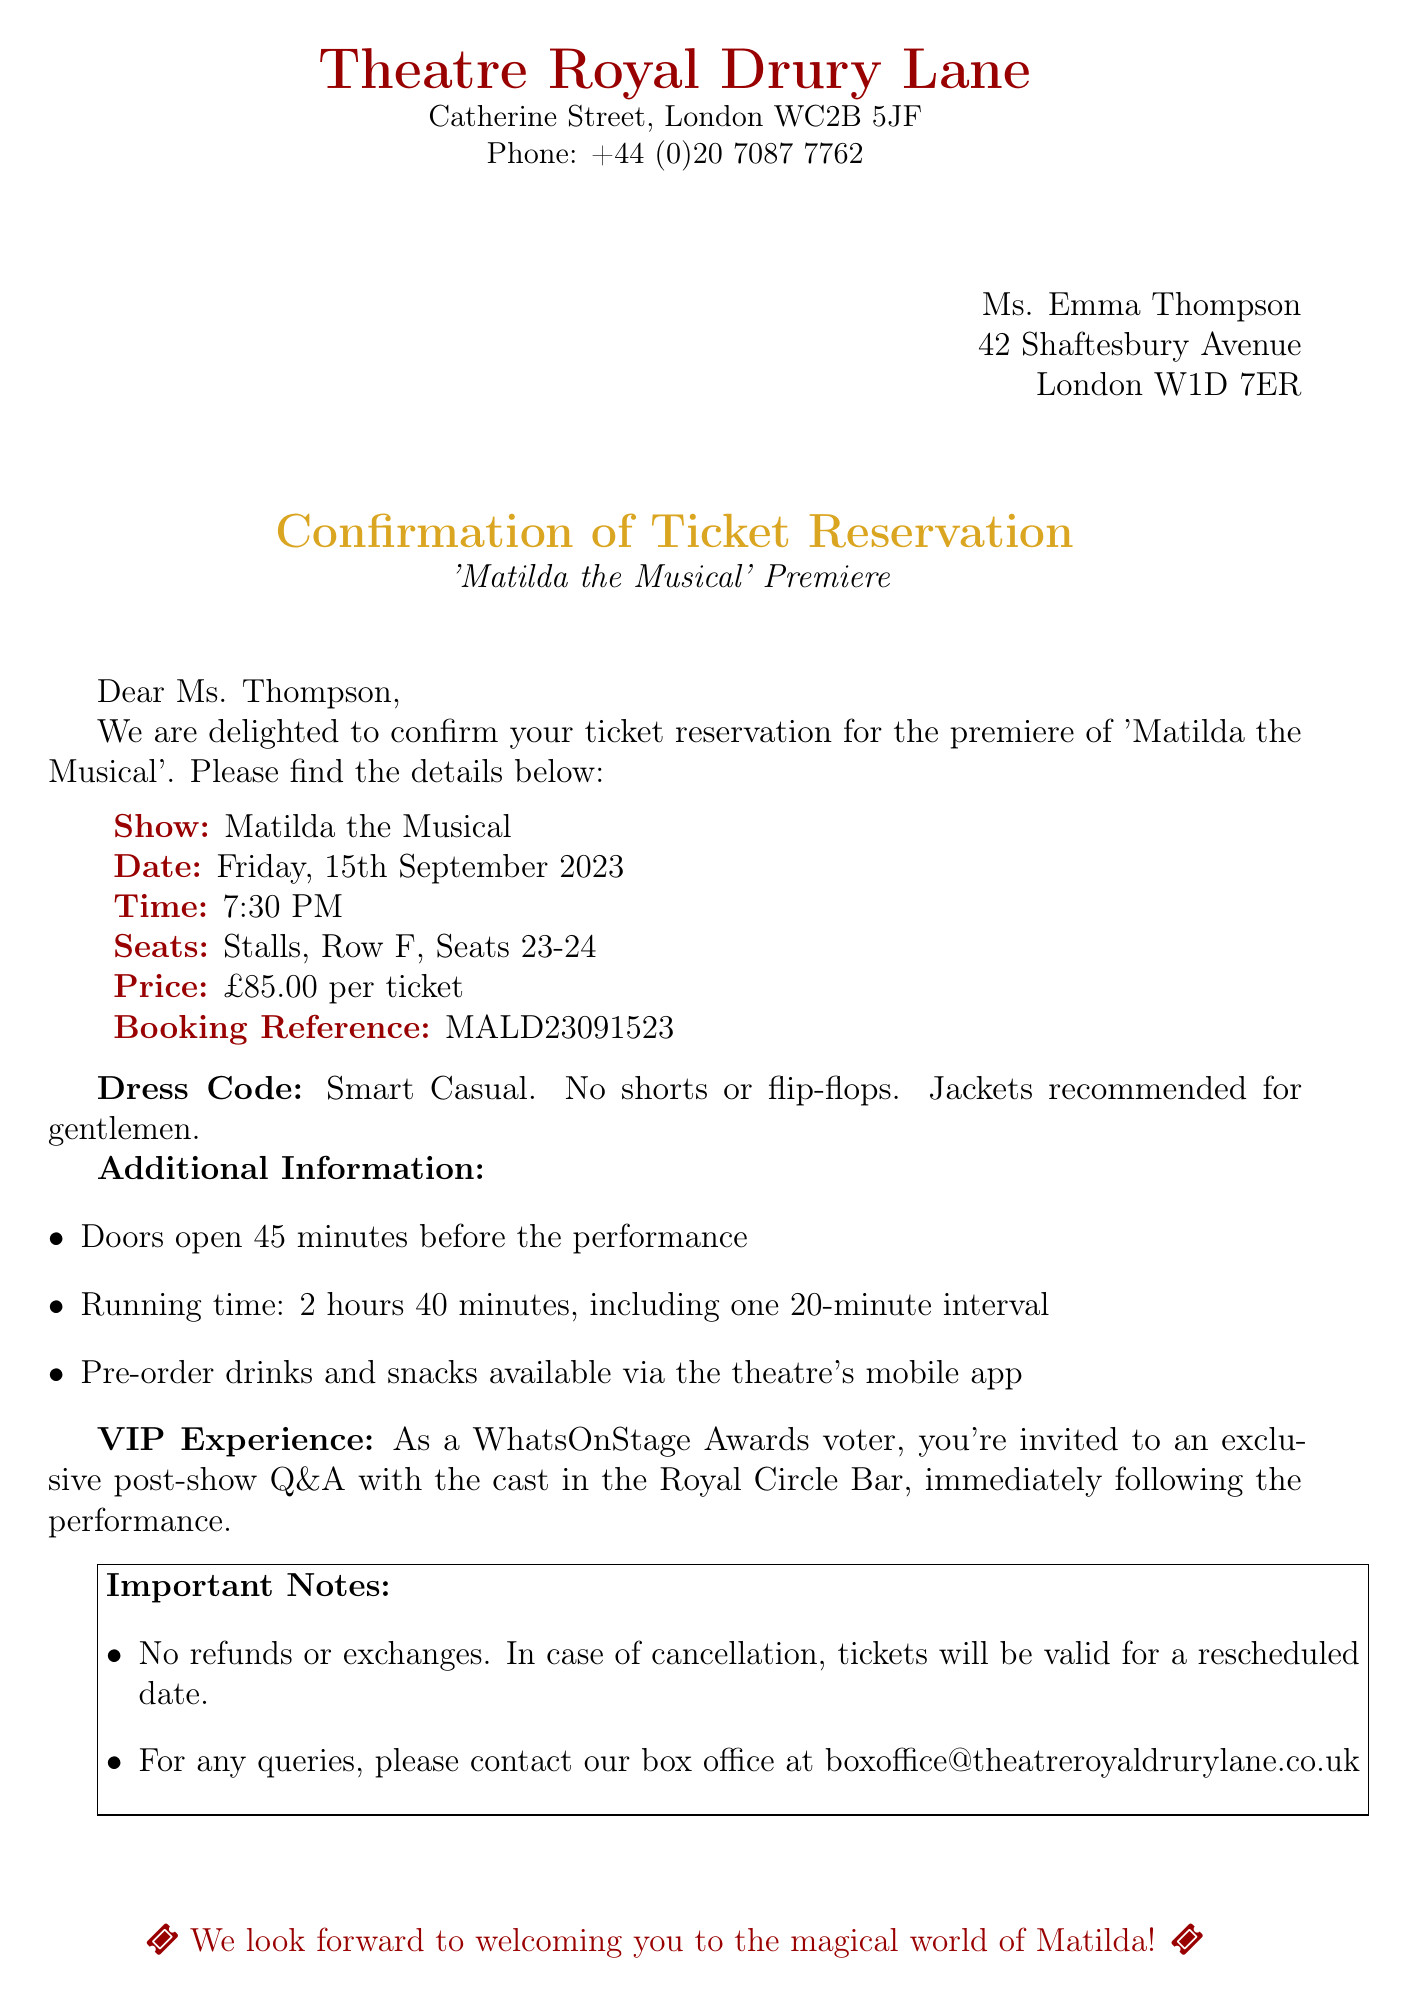What is the show title? The show title is explicitly mentioned as 'Matilda the Musical'.
Answer: Matilda the Musical What is the date of the performance? The date of the performance is stated in the reservation details as Friday, 15th September 2023.
Answer: Friday, 15th September 2023 What row are the seats located in? The reserved seat details specify that they are located in Row F.
Answer: Row F What is the price per ticket? The ticket price is listed in the details as £85.00 per ticket.
Answer: £85.00 per ticket What time does the show start? The performance time is clearly stated as 7:30 PM.
Answer: 7:30 PM What is the recommended dress code? The document states that the dress code is Smart Casual.
Answer: Smart Casual In which area will the post-show Q&A take place? The post-show Q&A is mentioned to take place in the Royal Circle Bar.
Answer: Royal Circle Bar What is the running time of the show? The running time, including the interval, is provided as 2 hours 40 minutes.
Answer: 2 hours 40 minutes Where can pre-ordered drinks and snacks be accessed? Pre-ordered drinks and snacks are available via the theatre's mobile app.
Answer: Theatre's mobile app 